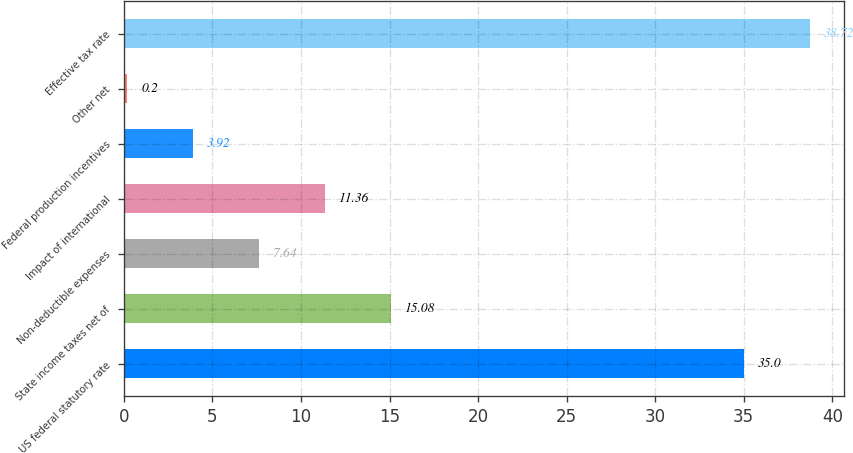<chart> <loc_0><loc_0><loc_500><loc_500><bar_chart><fcel>US federal statutory rate<fcel>State income taxes net of<fcel>Non-deductible expenses<fcel>Impact of international<fcel>Federal production incentives<fcel>Other net<fcel>Effective tax rate<nl><fcel>35<fcel>15.08<fcel>7.64<fcel>11.36<fcel>3.92<fcel>0.2<fcel>38.72<nl></chart> 